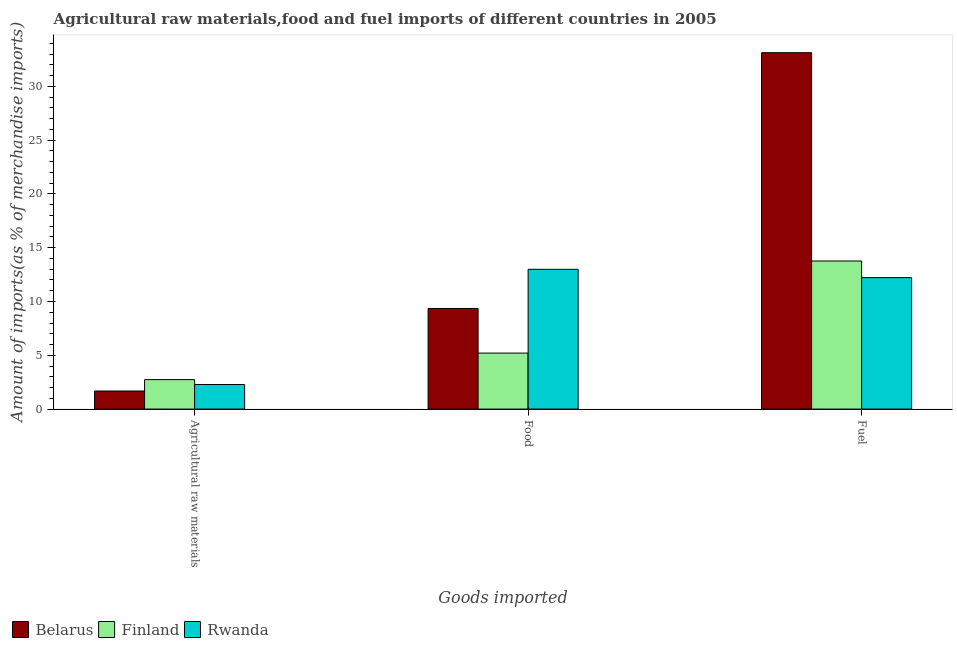How many different coloured bars are there?
Your answer should be compact. 3. Are the number of bars on each tick of the X-axis equal?
Give a very brief answer. Yes. How many bars are there on the 1st tick from the left?
Ensure brevity in your answer.  3. What is the label of the 1st group of bars from the left?
Keep it short and to the point. Agricultural raw materials. What is the percentage of fuel imports in Belarus?
Your response must be concise. 33.12. Across all countries, what is the maximum percentage of fuel imports?
Offer a very short reply. 33.12. Across all countries, what is the minimum percentage of raw materials imports?
Ensure brevity in your answer.  1.68. In which country was the percentage of fuel imports maximum?
Your response must be concise. Belarus. In which country was the percentage of fuel imports minimum?
Provide a succinct answer. Rwanda. What is the total percentage of raw materials imports in the graph?
Give a very brief answer. 6.7. What is the difference between the percentage of food imports in Belarus and that in Rwanda?
Offer a terse response. -3.64. What is the difference between the percentage of food imports in Belarus and the percentage of raw materials imports in Finland?
Ensure brevity in your answer.  6.61. What is the average percentage of raw materials imports per country?
Your answer should be very brief. 2.23. What is the difference between the percentage of raw materials imports and percentage of food imports in Rwanda?
Offer a very short reply. -10.71. What is the ratio of the percentage of fuel imports in Finland to that in Belarus?
Offer a terse response. 0.42. Is the percentage of fuel imports in Finland less than that in Belarus?
Give a very brief answer. Yes. Is the difference between the percentage of food imports in Belarus and Finland greater than the difference between the percentage of raw materials imports in Belarus and Finland?
Give a very brief answer. Yes. What is the difference between the highest and the second highest percentage of food imports?
Make the answer very short. 3.64. What is the difference between the highest and the lowest percentage of raw materials imports?
Offer a very short reply. 1.06. In how many countries, is the percentage of food imports greater than the average percentage of food imports taken over all countries?
Give a very brief answer. 2. What does the 3rd bar from the left in Fuel represents?
Your answer should be compact. Rwanda. What does the 2nd bar from the right in Food represents?
Keep it short and to the point. Finland. Is it the case that in every country, the sum of the percentage of raw materials imports and percentage of food imports is greater than the percentage of fuel imports?
Your response must be concise. No. How many bars are there?
Keep it short and to the point. 9. Are all the bars in the graph horizontal?
Offer a very short reply. No. What is the difference between two consecutive major ticks on the Y-axis?
Keep it short and to the point. 5. Are the values on the major ticks of Y-axis written in scientific E-notation?
Offer a very short reply. No. Does the graph contain any zero values?
Provide a short and direct response. No. Does the graph contain grids?
Provide a short and direct response. No. How many legend labels are there?
Ensure brevity in your answer.  3. What is the title of the graph?
Your answer should be very brief. Agricultural raw materials,food and fuel imports of different countries in 2005. What is the label or title of the X-axis?
Give a very brief answer. Goods imported. What is the label or title of the Y-axis?
Give a very brief answer. Amount of imports(as % of merchandise imports). What is the Amount of imports(as % of merchandise imports) in Belarus in Agricultural raw materials?
Offer a very short reply. 1.68. What is the Amount of imports(as % of merchandise imports) in Finland in Agricultural raw materials?
Your answer should be very brief. 2.74. What is the Amount of imports(as % of merchandise imports) in Rwanda in Agricultural raw materials?
Give a very brief answer. 2.28. What is the Amount of imports(as % of merchandise imports) of Belarus in Food?
Provide a short and direct response. 9.35. What is the Amount of imports(as % of merchandise imports) in Finland in Food?
Ensure brevity in your answer.  5.2. What is the Amount of imports(as % of merchandise imports) of Rwanda in Food?
Offer a very short reply. 12.99. What is the Amount of imports(as % of merchandise imports) of Belarus in Fuel?
Your response must be concise. 33.12. What is the Amount of imports(as % of merchandise imports) in Finland in Fuel?
Your answer should be compact. 13.76. What is the Amount of imports(as % of merchandise imports) in Rwanda in Fuel?
Make the answer very short. 12.22. Across all Goods imported, what is the maximum Amount of imports(as % of merchandise imports) in Belarus?
Your answer should be compact. 33.12. Across all Goods imported, what is the maximum Amount of imports(as % of merchandise imports) of Finland?
Make the answer very short. 13.76. Across all Goods imported, what is the maximum Amount of imports(as % of merchandise imports) of Rwanda?
Offer a terse response. 12.99. Across all Goods imported, what is the minimum Amount of imports(as % of merchandise imports) in Belarus?
Offer a very short reply. 1.68. Across all Goods imported, what is the minimum Amount of imports(as % of merchandise imports) in Finland?
Your response must be concise. 2.74. Across all Goods imported, what is the minimum Amount of imports(as % of merchandise imports) in Rwanda?
Give a very brief answer. 2.28. What is the total Amount of imports(as % of merchandise imports) in Belarus in the graph?
Your answer should be compact. 44.15. What is the total Amount of imports(as % of merchandise imports) in Finland in the graph?
Give a very brief answer. 21.7. What is the total Amount of imports(as % of merchandise imports) of Rwanda in the graph?
Keep it short and to the point. 27.49. What is the difference between the Amount of imports(as % of merchandise imports) in Belarus in Agricultural raw materials and that in Food?
Keep it short and to the point. -7.67. What is the difference between the Amount of imports(as % of merchandise imports) in Finland in Agricultural raw materials and that in Food?
Your answer should be compact. -2.47. What is the difference between the Amount of imports(as % of merchandise imports) of Rwanda in Agricultural raw materials and that in Food?
Offer a terse response. -10.71. What is the difference between the Amount of imports(as % of merchandise imports) of Belarus in Agricultural raw materials and that in Fuel?
Ensure brevity in your answer.  -31.44. What is the difference between the Amount of imports(as % of merchandise imports) in Finland in Agricultural raw materials and that in Fuel?
Keep it short and to the point. -11.02. What is the difference between the Amount of imports(as % of merchandise imports) of Rwanda in Agricultural raw materials and that in Fuel?
Your answer should be compact. -9.93. What is the difference between the Amount of imports(as % of merchandise imports) of Belarus in Food and that in Fuel?
Ensure brevity in your answer.  -23.78. What is the difference between the Amount of imports(as % of merchandise imports) in Finland in Food and that in Fuel?
Offer a very short reply. -8.56. What is the difference between the Amount of imports(as % of merchandise imports) of Rwanda in Food and that in Fuel?
Provide a succinct answer. 0.77. What is the difference between the Amount of imports(as % of merchandise imports) in Belarus in Agricultural raw materials and the Amount of imports(as % of merchandise imports) in Finland in Food?
Offer a very short reply. -3.52. What is the difference between the Amount of imports(as % of merchandise imports) of Belarus in Agricultural raw materials and the Amount of imports(as % of merchandise imports) of Rwanda in Food?
Offer a terse response. -11.31. What is the difference between the Amount of imports(as % of merchandise imports) of Finland in Agricultural raw materials and the Amount of imports(as % of merchandise imports) of Rwanda in Food?
Make the answer very short. -10.25. What is the difference between the Amount of imports(as % of merchandise imports) of Belarus in Agricultural raw materials and the Amount of imports(as % of merchandise imports) of Finland in Fuel?
Your answer should be very brief. -12.08. What is the difference between the Amount of imports(as % of merchandise imports) of Belarus in Agricultural raw materials and the Amount of imports(as % of merchandise imports) of Rwanda in Fuel?
Your answer should be very brief. -10.54. What is the difference between the Amount of imports(as % of merchandise imports) of Finland in Agricultural raw materials and the Amount of imports(as % of merchandise imports) of Rwanda in Fuel?
Provide a short and direct response. -9.48. What is the difference between the Amount of imports(as % of merchandise imports) in Belarus in Food and the Amount of imports(as % of merchandise imports) in Finland in Fuel?
Provide a short and direct response. -4.42. What is the difference between the Amount of imports(as % of merchandise imports) in Belarus in Food and the Amount of imports(as % of merchandise imports) in Rwanda in Fuel?
Offer a very short reply. -2.87. What is the difference between the Amount of imports(as % of merchandise imports) in Finland in Food and the Amount of imports(as % of merchandise imports) in Rwanda in Fuel?
Give a very brief answer. -7.01. What is the average Amount of imports(as % of merchandise imports) in Belarus per Goods imported?
Keep it short and to the point. 14.72. What is the average Amount of imports(as % of merchandise imports) in Finland per Goods imported?
Keep it short and to the point. 7.23. What is the average Amount of imports(as % of merchandise imports) of Rwanda per Goods imported?
Keep it short and to the point. 9.16. What is the difference between the Amount of imports(as % of merchandise imports) in Belarus and Amount of imports(as % of merchandise imports) in Finland in Agricultural raw materials?
Your answer should be very brief. -1.06. What is the difference between the Amount of imports(as % of merchandise imports) in Belarus and Amount of imports(as % of merchandise imports) in Rwanda in Agricultural raw materials?
Make the answer very short. -0.6. What is the difference between the Amount of imports(as % of merchandise imports) in Finland and Amount of imports(as % of merchandise imports) in Rwanda in Agricultural raw materials?
Keep it short and to the point. 0.46. What is the difference between the Amount of imports(as % of merchandise imports) in Belarus and Amount of imports(as % of merchandise imports) in Finland in Food?
Your answer should be very brief. 4.14. What is the difference between the Amount of imports(as % of merchandise imports) in Belarus and Amount of imports(as % of merchandise imports) in Rwanda in Food?
Your answer should be compact. -3.64. What is the difference between the Amount of imports(as % of merchandise imports) of Finland and Amount of imports(as % of merchandise imports) of Rwanda in Food?
Your answer should be very brief. -7.79. What is the difference between the Amount of imports(as % of merchandise imports) of Belarus and Amount of imports(as % of merchandise imports) of Finland in Fuel?
Your response must be concise. 19.36. What is the difference between the Amount of imports(as % of merchandise imports) of Belarus and Amount of imports(as % of merchandise imports) of Rwanda in Fuel?
Your response must be concise. 20.91. What is the difference between the Amount of imports(as % of merchandise imports) of Finland and Amount of imports(as % of merchandise imports) of Rwanda in Fuel?
Keep it short and to the point. 1.55. What is the ratio of the Amount of imports(as % of merchandise imports) of Belarus in Agricultural raw materials to that in Food?
Make the answer very short. 0.18. What is the ratio of the Amount of imports(as % of merchandise imports) of Finland in Agricultural raw materials to that in Food?
Provide a succinct answer. 0.53. What is the ratio of the Amount of imports(as % of merchandise imports) of Rwanda in Agricultural raw materials to that in Food?
Offer a terse response. 0.18. What is the ratio of the Amount of imports(as % of merchandise imports) of Belarus in Agricultural raw materials to that in Fuel?
Offer a terse response. 0.05. What is the ratio of the Amount of imports(as % of merchandise imports) in Finland in Agricultural raw materials to that in Fuel?
Offer a very short reply. 0.2. What is the ratio of the Amount of imports(as % of merchandise imports) of Rwanda in Agricultural raw materials to that in Fuel?
Your answer should be compact. 0.19. What is the ratio of the Amount of imports(as % of merchandise imports) in Belarus in Food to that in Fuel?
Keep it short and to the point. 0.28. What is the ratio of the Amount of imports(as % of merchandise imports) of Finland in Food to that in Fuel?
Your answer should be very brief. 0.38. What is the ratio of the Amount of imports(as % of merchandise imports) in Rwanda in Food to that in Fuel?
Ensure brevity in your answer.  1.06. What is the difference between the highest and the second highest Amount of imports(as % of merchandise imports) of Belarus?
Your answer should be compact. 23.78. What is the difference between the highest and the second highest Amount of imports(as % of merchandise imports) of Finland?
Give a very brief answer. 8.56. What is the difference between the highest and the second highest Amount of imports(as % of merchandise imports) of Rwanda?
Offer a terse response. 0.77. What is the difference between the highest and the lowest Amount of imports(as % of merchandise imports) in Belarus?
Keep it short and to the point. 31.44. What is the difference between the highest and the lowest Amount of imports(as % of merchandise imports) in Finland?
Provide a succinct answer. 11.02. What is the difference between the highest and the lowest Amount of imports(as % of merchandise imports) of Rwanda?
Keep it short and to the point. 10.71. 